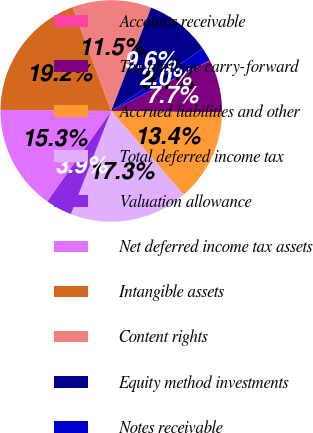Convert chart to OTSL. <chart><loc_0><loc_0><loc_500><loc_500><pie_chart><fcel>Accounts receivable<fcel>Tax attribute carry-forward<fcel>Accrued liabilities and other<fcel>Total deferred income tax<fcel>Valuation allowance<fcel>Net deferred income tax assets<fcel>Intangible assets<fcel>Content rights<fcel>Equity method investments<fcel>Notes receivable<nl><fcel>0.06%<fcel>7.71%<fcel>13.44%<fcel>17.27%<fcel>3.88%<fcel>15.35%<fcel>19.18%<fcel>11.53%<fcel>9.62%<fcel>1.97%<nl></chart> 